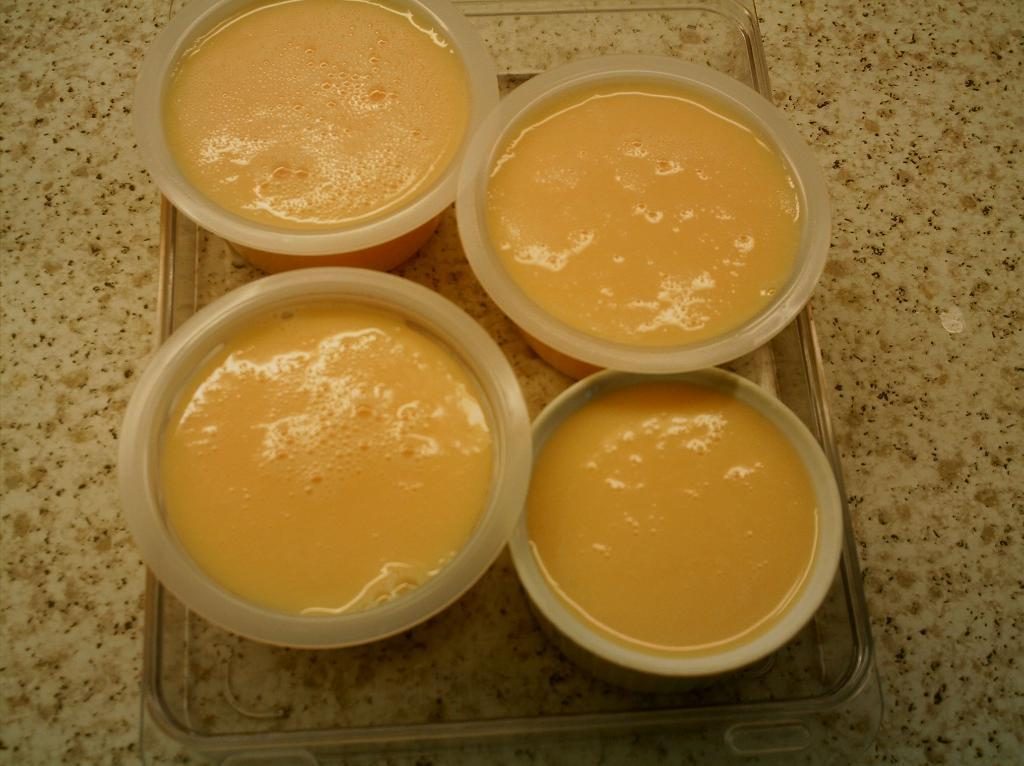What piece of furniture is present at the bottom of the image? There is a table at the bottom of the image. What is placed on the table? There is a tray on the table. What can be found inside the tray? The tray contains some cups. Can you hear the collar of the dog in the image? There is no dog or collar present in the image. 